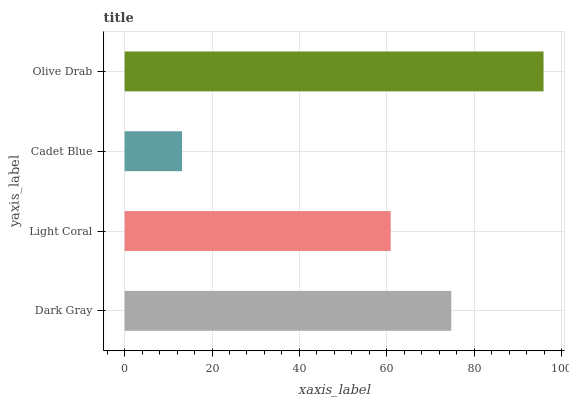Is Cadet Blue the minimum?
Answer yes or no. Yes. Is Olive Drab the maximum?
Answer yes or no. Yes. Is Light Coral the minimum?
Answer yes or no. No. Is Light Coral the maximum?
Answer yes or no. No. Is Dark Gray greater than Light Coral?
Answer yes or no. Yes. Is Light Coral less than Dark Gray?
Answer yes or no. Yes. Is Light Coral greater than Dark Gray?
Answer yes or no. No. Is Dark Gray less than Light Coral?
Answer yes or no. No. Is Dark Gray the high median?
Answer yes or no. Yes. Is Light Coral the low median?
Answer yes or no. Yes. Is Olive Drab the high median?
Answer yes or no. No. Is Dark Gray the low median?
Answer yes or no. No. 